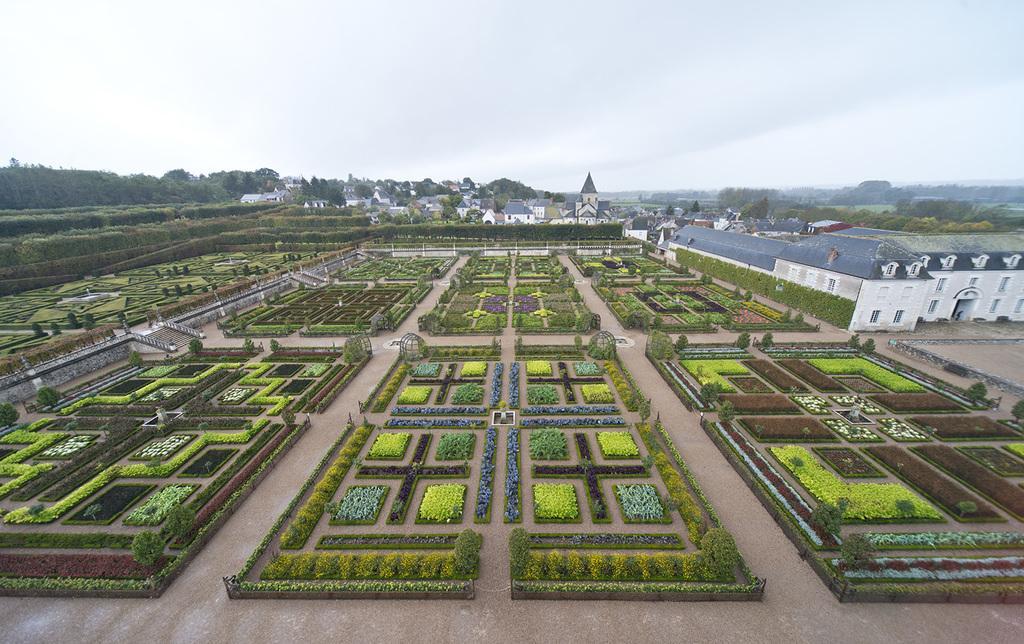How would you summarize this image in a sentence or two? In this image we can see a group of plants with flowers which are placed in an order and some houses with roof and windows. On the backside we can see a group of trees, buildings and the sky which looks cloudy. 